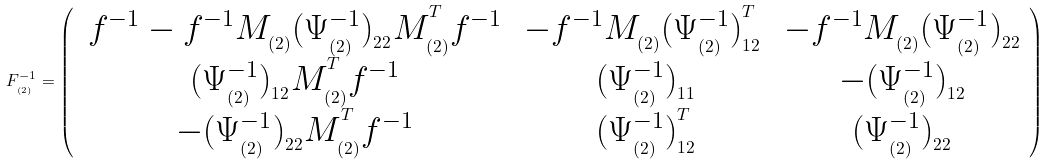Convert formula to latex. <formula><loc_0><loc_0><loc_500><loc_500>F _ { _ { ( 2 ) } } ^ { - 1 } = \left ( \begin{array} { c c c } \, f ^ { - 1 } - f ^ { - 1 } M _ { _ { ( 2 ) } } ( \Psi _ { _ { ( 2 ) } } ^ { - 1 } ) _ { _ { 2 2 } } M _ { _ { ( 2 ) } } ^ { ^ { T } } f ^ { - 1 } \, & - f ^ { - 1 } M _ { _ { ( 2 ) } } ( \Psi _ { _ { ( 2 ) } } ^ { - 1 } ) _ { _ { 1 2 } } ^ { ^ { T } } \, & - f ^ { - 1 } M _ { _ { ( 2 ) } } ( \Psi _ { _ { ( 2 ) } } ^ { - 1 } ) _ { _ { 2 2 } } \\ ( \Psi _ { _ { ( 2 ) } } ^ { - 1 } ) _ { _ { 1 2 } } M _ { _ { ( 2 ) } } ^ { ^ { T } } f ^ { - 1 } & ( \Psi _ { _ { ( 2 ) } } ^ { - 1 } ) _ { _ { 1 1 } } & - ( \Psi _ { _ { ( 2 ) } } ^ { - 1 } ) _ { _ { 1 2 } } \\ - ( \Psi _ { _ { ( 2 ) } } ^ { - 1 } ) _ { _ { 2 2 } } M _ { _ { ( 2 ) } } ^ { ^ { T } } f ^ { - 1 } & ( \Psi _ { _ { ( 2 ) } } ^ { - 1 } ) _ { _ { 1 2 } } ^ { ^ { T } } & ( \Psi _ { _ { ( 2 ) } } ^ { - 1 } ) _ { _ { 2 2 } } \end{array} \right )</formula> 